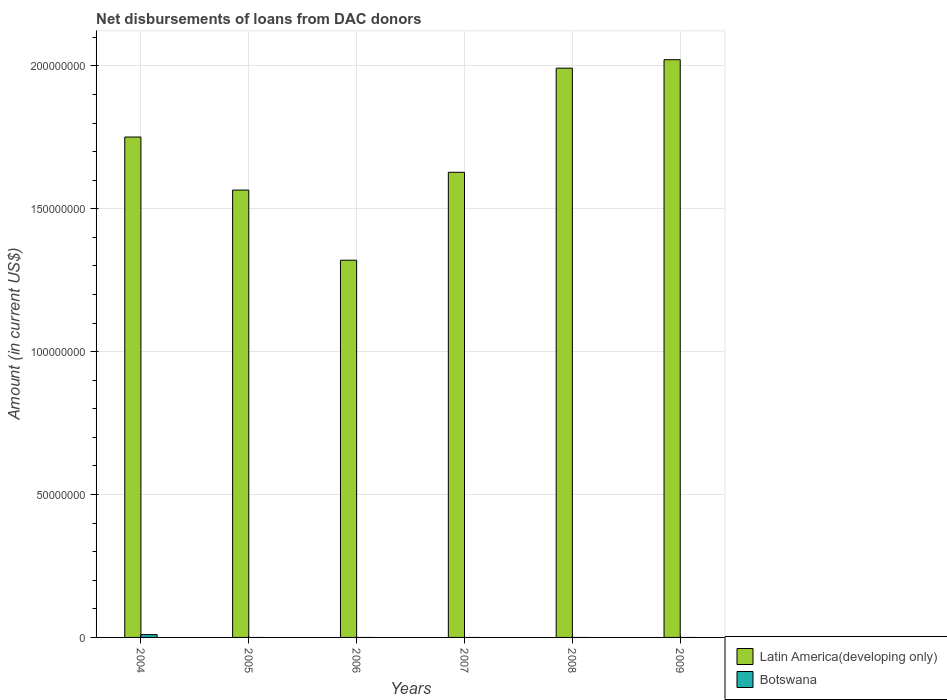How many different coloured bars are there?
Offer a terse response. 2. Are the number of bars on each tick of the X-axis equal?
Offer a very short reply. No. Across all years, what is the maximum amount of loans disbursed in Botswana?
Your answer should be very brief. 9.91e+05. In which year was the amount of loans disbursed in Latin America(developing only) maximum?
Keep it short and to the point. 2009. What is the total amount of loans disbursed in Latin America(developing only) in the graph?
Your answer should be very brief. 1.03e+09. What is the difference between the amount of loans disbursed in Latin America(developing only) in 2005 and that in 2006?
Offer a very short reply. 2.45e+07. What is the difference between the amount of loans disbursed in Botswana in 2008 and the amount of loans disbursed in Latin America(developing only) in 2005?
Keep it short and to the point. -1.57e+08. What is the average amount of loans disbursed in Botswana per year?
Keep it short and to the point. 1.65e+05. In the year 2004, what is the difference between the amount of loans disbursed in Latin America(developing only) and amount of loans disbursed in Botswana?
Keep it short and to the point. 1.74e+08. What is the ratio of the amount of loans disbursed in Latin America(developing only) in 2004 to that in 2009?
Your answer should be very brief. 0.87. Is the amount of loans disbursed in Latin America(developing only) in 2004 less than that in 2006?
Give a very brief answer. No. What is the difference between the highest and the second highest amount of loans disbursed in Latin America(developing only)?
Offer a very short reply. 2.96e+06. What is the difference between the highest and the lowest amount of loans disbursed in Botswana?
Your answer should be very brief. 9.91e+05. In how many years, is the amount of loans disbursed in Botswana greater than the average amount of loans disbursed in Botswana taken over all years?
Your answer should be compact. 1. Is the sum of the amount of loans disbursed in Latin America(developing only) in 2005 and 2007 greater than the maximum amount of loans disbursed in Botswana across all years?
Offer a terse response. Yes. How many years are there in the graph?
Your answer should be very brief. 6. Are the values on the major ticks of Y-axis written in scientific E-notation?
Offer a terse response. No. How many legend labels are there?
Your answer should be very brief. 2. How are the legend labels stacked?
Offer a very short reply. Vertical. What is the title of the graph?
Offer a very short reply. Net disbursements of loans from DAC donors. Does "Tajikistan" appear as one of the legend labels in the graph?
Provide a succinct answer. No. What is the label or title of the Y-axis?
Provide a short and direct response. Amount (in current US$). What is the Amount (in current US$) of Latin America(developing only) in 2004?
Offer a very short reply. 1.75e+08. What is the Amount (in current US$) of Botswana in 2004?
Ensure brevity in your answer.  9.91e+05. What is the Amount (in current US$) of Latin America(developing only) in 2005?
Keep it short and to the point. 1.57e+08. What is the Amount (in current US$) in Botswana in 2005?
Give a very brief answer. 0. What is the Amount (in current US$) of Latin America(developing only) in 2006?
Keep it short and to the point. 1.32e+08. What is the Amount (in current US$) of Botswana in 2006?
Make the answer very short. 0. What is the Amount (in current US$) in Latin America(developing only) in 2007?
Your answer should be compact. 1.63e+08. What is the Amount (in current US$) in Latin America(developing only) in 2008?
Your answer should be very brief. 1.99e+08. What is the Amount (in current US$) in Botswana in 2008?
Keep it short and to the point. 0. What is the Amount (in current US$) in Latin America(developing only) in 2009?
Offer a very short reply. 2.02e+08. What is the Amount (in current US$) of Botswana in 2009?
Your answer should be very brief. 0. Across all years, what is the maximum Amount (in current US$) in Latin America(developing only)?
Your answer should be very brief. 2.02e+08. Across all years, what is the maximum Amount (in current US$) of Botswana?
Your answer should be compact. 9.91e+05. Across all years, what is the minimum Amount (in current US$) in Latin America(developing only)?
Make the answer very short. 1.32e+08. Across all years, what is the minimum Amount (in current US$) of Botswana?
Provide a succinct answer. 0. What is the total Amount (in current US$) of Latin America(developing only) in the graph?
Provide a short and direct response. 1.03e+09. What is the total Amount (in current US$) of Botswana in the graph?
Ensure brevity in your answer.  9.91e+05. What is the difference between the Amount (in current US$) in Latin America(developing only) in 2004 and that in 2005?
Your answer should be compact. 1.86e+07. What is the difference between the Amount (in current US$) of Latin America(developing only) in 2004 and that in 2006?
Give a very brief answer. 4.31e+07. What is the difference between the Amount (in current US$) in Latin America(developing only) in 2004 and that in 2007?
Provide a succinct answer. 1.23e+07. What is the difference between the Amount (in current US$) in Latin America(developing only) in 2004 and that in 2008?
Keep it short and to the point. -2.41e+07. What is the difference between the Amount (in current US$) in Latin America(developing only) in 2004 and that in 2009?
Provide a short and direct response. -2.71e+07. What is the difference between the Amount (in current US$) of Latin America(developing only) in 2005 and that in 2006?
Offer a terse response. 2.45e+07. What is the difference between the Amount (in current US$) in Latin America(developing only) in 2005 and that in 2007?
Your response must be concise. -6.22e+06. What is the difference between the Amount (in current US$) in Latin America(developing only) in 2005 and that in 2008?
Your answer should be very brief. -4.27e+07. What is the difference between the Amount (in current US$) of Latin America(developing only) in 2005 and that in 2009?
Offer a terse response. -4.56e+07. What is the difference between the Amount (in current US$) of Latin America(developing only) in 2006 and that in 2007?
Offer a very short reply. -3.08e+07. What is the difference between the Amount (in current US$) in Latin America(developing only) in 2006 and that in 2008?
Ensure brevity in your answer.  -6.72e+07. What is the difference between the Amount (in current US$) of Latin America(developing only) in 2006 and that in 2009?
Your response must be concise. -7.02e+07. What is the difference between the Amount (in current US$) in Latin America(developing only) in 2007 and that in 2008?
Your response must be concise. -3.64e+07. What is the difference between the Amount (in current US$) in Latin America(developing only) in 2007 and that in 2009?
Offer a very short reply. -3.94e+07. What is the difference between the Amount (in current US$) in Latin America(developing only) in 2008 and that in 2009?
Your response must be concise. -2.96e+06. What is the average Amount (in current US$) in Latin America(developing only) per year?
Your answer should be compact. 1.71e+08. What is the average Amount (in current US$) of Botswana per year?
Keep it short and to the point. 1.65e+05. In the year 2004, what is the difference between the Amount (in current US$) of Latin America(developing only) and Amount (in current US$) of Botswana?
Keep it short and to the point. 1.74e+08. What is the ratio of the Amount (in current US$) of Latin America(developing only) in 2004 to that in 2005?
Your answer should be very brief. 1.12. What is the ratio of the Amount (in current US$) of Latin America(developing only) in 2004 to that in 2006?
Keep it short and to the point. 1.33. What is the ratio of the Amount (in current US$) in Latin America(developing only) in 2004 to that in 2007?
Offer a terse response. 1.08. What is the ratio of the Amount (in current US$) in Latin America(developing only) in 2004 to that in 2008?
Ensure brevity in your answer.  0.88. What is the ratio of the Amount (in current US$) in Latin America(developing only) in 2004 to that in 2009?
Your answer should be very brief. 0.87. What is the ratio of the Amount (in current US$) of Latin America(developing only) in 2005 to that in 2006?
Ensure brevity in your answer.  1.19. What is the ratio of the Amount (in current US$) in Latin America(developing only) in 2005 to that in 2007?
Offer a terse response. 0.96. What is the ratio of the Amount (in current US$) of Latin America(developing only) in 2005 to that in 2008?
Provide a succinct answer. 0.79. What is the ratio of the Amount (in current US$) of Latin America(developing only) in 2005 to that in 2009?
Make the answer very short. 0.77. What is the ratio of the Amount (in current US$) of Latin America(developing only) in 2006 to that in 2007?
Give a very brief answer. 0.81. What is the ratio of the Amount (in current US$) of Latin America(developing only) in 2006 to that in 2008?
Make the answer very short. 0.66. What is the ratio of the Amount (in current US$) of Latin America(developing only) in 2006 to that in 2009?
Ensure brevity in your answer.  0.65. What is the ratio of the Amount (in current US$) in Latin America(developing only) in 2007 to that in 2008?
Your answer should be compact. 0.82. What is the ratio of the Amount (in current US$) in Latin America(developing only) in 2007 to that in 2009?
Your response must be concise. 0.81. What is the ratio of the Amount (in current US$) of Latin America(developing only) in 2008 to that in 2009?
Keep it short and to the point. 0.99. What is the difference between the highest and the second highest Amount (in current US$) of Latin America(developing only)?
Keep it short and to the point. 2.96e+06. What is the difference between the highest and the lowest Amount (in current US$) of Latin America(developing only)?
Your answer should be compact. 7.02e+07. What is the difference between the highest and the lowest Amount (in current US$) of Botswana?
Give a very brief answer. 9.91e+05. 